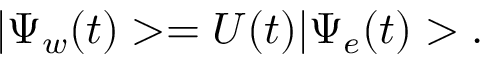<formula> <loc_0><loc_0><loc_500><loc_500>| \Psi _ { w } ( t ) > = U ( t ) | \Psi _ { e } ( t ) > .</formula> 